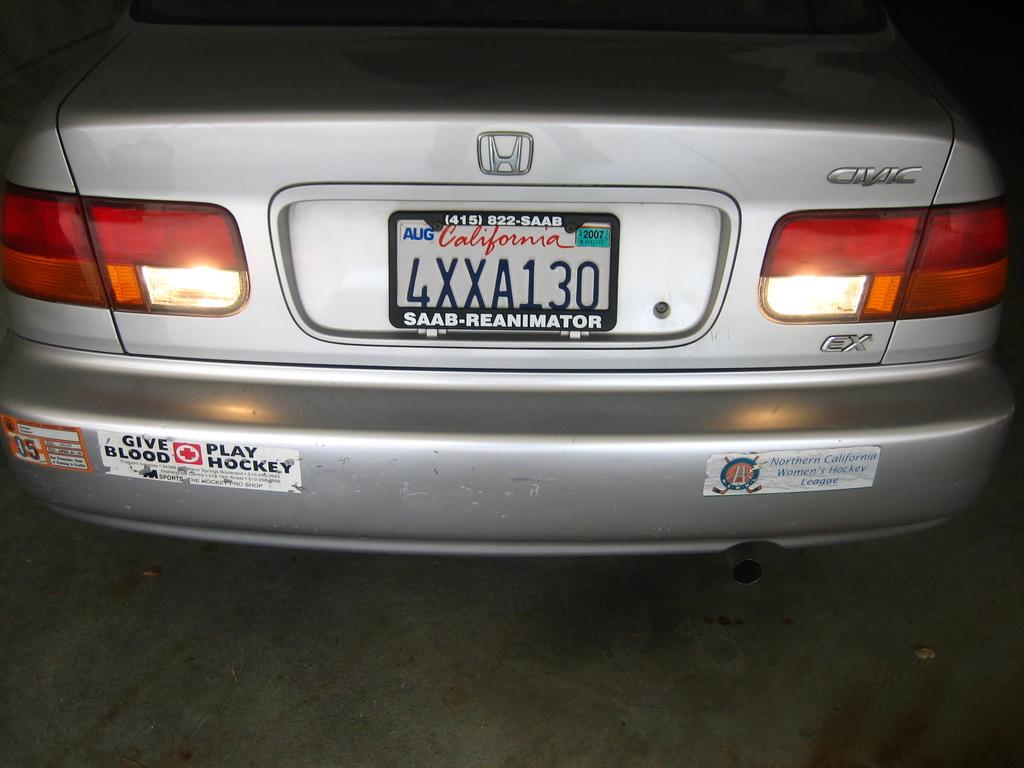What model is this car?
Offer a terse response. Civic. 